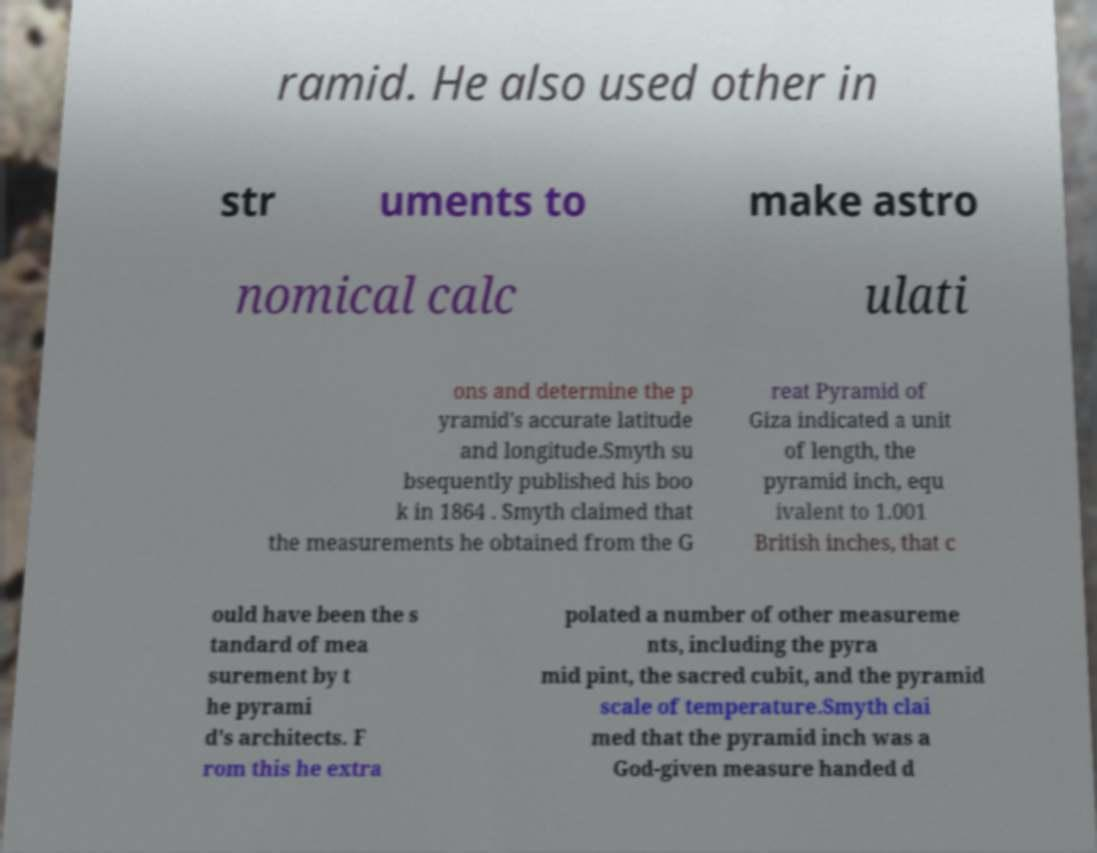For documentation purposes, I need the text within this image transcribed. Could you provide that? ramid. He also used other in str uments to make astro nomical calc ulati ons and determine the p yramid's accurate latitude and longitude.Smyth su bsequently published his boo k in 1864 . Smyth claimed that the measurements he obtained from the G reat Pyramid of Giza indicated a unit of length, the pyramid inch, equ ivalent to 1.001 British inches, that c ould have been the s tandard of mea surement by t he pyrami d's architects. F rom this he extra polated a number of other measureme nts, including the pyra mid pint, the sacred cubit, and the pyramid scale of temperature.Smyth clai med that the pyramid inch was a God-given measure handed d 